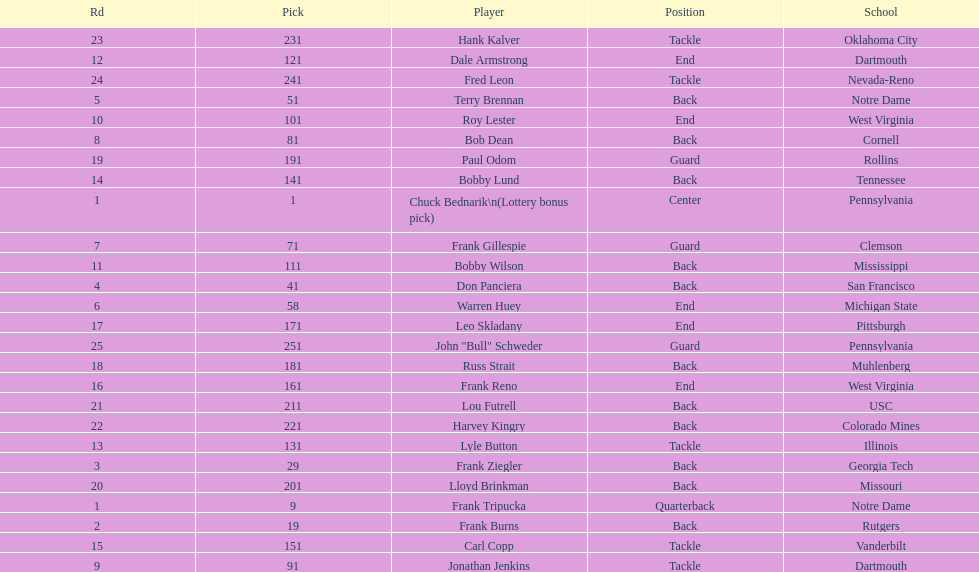Who was picked after roy lester? Bobby Wilson. 